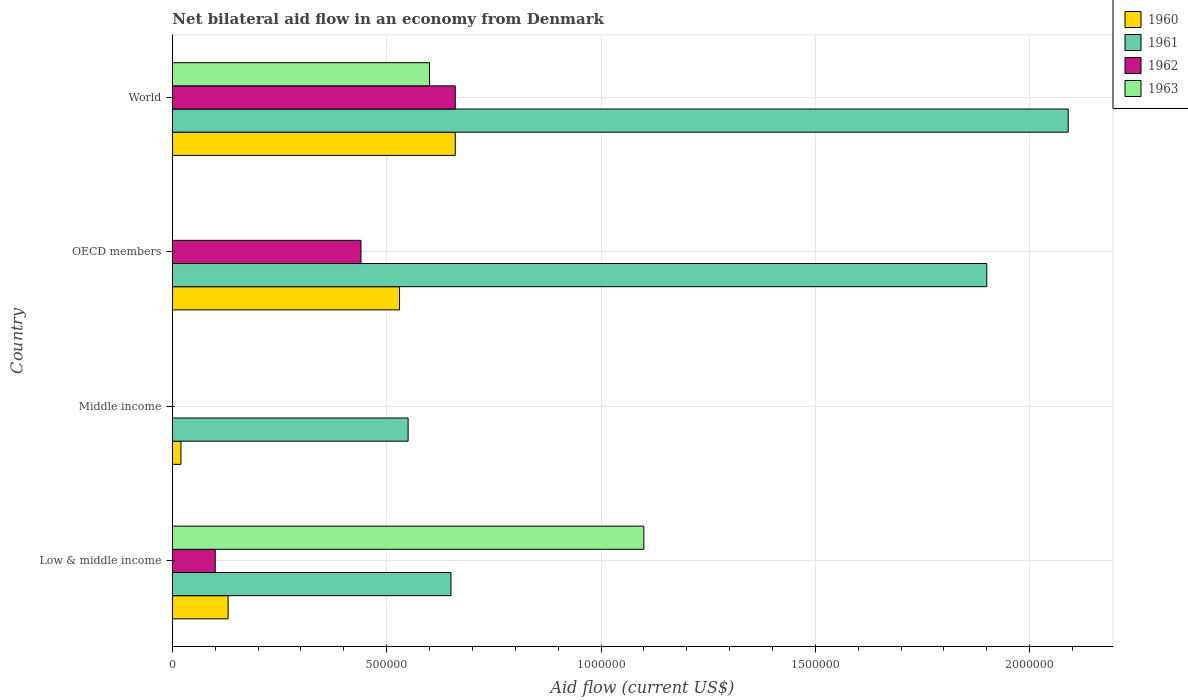Are the number of bars on each tick of the Y-axis equal?
Provide a succinct answer. No. How many bars are there on the 1st tick from the bottom?
Your answer should be very brief. 4. What is the label of the 2nd group of bars from the top?
Ensure brevity in your answer.  OECD members. What is the net bilateral aid flow in 1963 in Low & middle income?
Provide a succinct answer. 1.10e+06. Across all countries, what is the maximum net bilateral aid flow in 1963?
Your response must be concise. 1.10e+06. What is the total net bilateral aid flow in 1963 in the graph?
Your answer should be very brief. 1.70e+06. What is the average net bilateral aid flow in 1960 per country?
Provide a succinct answer. 3.35e+05. What is the difference between the net bilateral aid flow in 1961 and net bilateral aid flow in 1963 in World?
Keep it short and to the point. 1.49e+06. What is the ratio of the net bilateral aid flow in 1961 in Middle income to that in OECD members?
Offer a very short reply. 0.29. What is the difference between the highest and the lowest net bilateral aid flow in 1963?
Your answer should be compact. 1.10e+06. Are the values on the major ticks of X-axis written in scientific E-notation?
Provide a succinct answer. No. Does the graph contain any zero values?
Provide a short and direct response. Yes. Does the graph contain grids?
Keep it short and to the point. Yes. Where does the legend appear in the graph?
Your response must be concise. Top right. What is the title of the graph?
Give a very brief answer. Net bilateral aid flow in an economy from Denmark. Does "1987" appear as one of the legend labels in the graph?
Your response must be concise. No. What is the label or title of the X-axis?
Offer a very short reply. Aid flow (current US$). What is the label or title of the Y-axis?
Offer a terse response. Country. What is the Aid flow (current US$) of 1960 in Low & middle income?
Offer a terse response. 1.30e+05. What is the Aid flow (current US$) in 1961 in Low & middle income?
Provide a short and direct response. 6.50e+05. What is the Aid flow (current US$) in 1962 in Low & middle income?
Keep it short and to the point. 1.00e+05. What is the Aid flow (current US$) of 1963 in Low & middle income?
Offer a very short reply. 1.10e+06. What is the Aid flow (current US$) of 1960 in Middle income?
Keep it short and to the point. 2.00e+04. What is the Aid flow (current US$) in 1960 in OECD members?
Offer a terse response. 5.30e+05. What is the Aid flow (current US$) of 1961 in OECD members?
Make the answer very short. 1.90e+06. What is the Aid flow (current US$) in 1962 in OECD members?
Your answer should be compact. 4.40e+05. What is the Aid flow (current US$) in 1961 in World?
Your answer should be compact. 2.09e+06. Across all countries, what is the maximum Aid flow (current US$) in 1961?
Make the answer very short. 2.09e+06. Across all countries, what is the maximum Aid flow (current US$) of 1962?
Your answer should be compact. 6.60e+05. Across all countries, what is the maximum Aid flow (current US$) in 1963?
Ensure brevity in your answer.  1.10e+06. Across all countries, what is the minimum Aid flow (current US$) of 1960?
Offer a terse response. 2.00e+04. What is the total Aid flow (current US$) in 1960 in the graph?
Your response must be concise. 1.34e+06. What is the total Aid flow (current US$) in 1961 in the graph?
Ensure brevity in your answer.  5.19e+06. What is the total Aid flow (current US$) of 1962 in the graph?
Give a very brief answer. 1.20e+06. What is the total Aid flow (current US$) in 1963 in the graph?
Your response must be concise. 1.70e+06. What is the difference between the Aid flow (current US$) in 1960 in Low & middle income and that in OECD members?
Offer a very short reply. -4.00e+05. What is the difference between the Aid flow (current US$) in 1961 in Low & middle income and that in OECD members?
Your answer should be very brief. -1.25e+06. What is the difference between the Aid flow (current US$) in 1962 in Low & middle income and that in OECD members?
Ensure brevity in your answer.  -3.40e+05. What is the difference between the Aid flow (current US$) of 1960 in Low & middle income and that in World?
Offer a terse response. -5.30e+05. What is the difference between the Aid flow (current US$) in 1961 in Low & middle income and that in World?
Keep it short and to the point. -1.44e+06. What is the difference between the Aid flow (current US$) of 1962 in Low & middle income and that in World?
Offer a very short reply. -5.60e+05. What is the difference between the Aid flow (current US$) of 1963 in Low & middle income and that in World?
Offer a terse response. 5.00e+05. What is the difference between the Aid flow (current US$) in 1960 in Middle income and that in OECD members?
Provide a succinct answer. -5.10e+05. What is the difference between the Aid flow (current US$) of 1961 in Middle income and that in OECD members?
Offer a very short reply. -1.35e+06. What is the difference between the Aid flow (current US$) in 1960 in Middle income and that in World?
Your response must be concise. -6.40e+05. What is the difference between the Aid flow (current US$) in 1961 in Middle income and that in World?
Your answer should be compact. -1.54e+06. What is the difference between the Aid flow (current US$) of 1960 in Low & middle income and the Aid flow (current US$) of 1961 in Middle income?
Your answer should be compact. -4.20e+05. What is the difference between the Aid flow (current US$) in 1960 in Low & middle income and the Aid flow (current US$) in 1961 in OECD members?
Keep it short and to the point. -1.77e+06. What is the difference between the Aid flow (current US$) of 1960 in Low & middle income and the Aid flow (current US$) of 1962 in OECD members?
Your answer should be compact. -3.10e+05. What is the difference between the Aid flow (current US$) of 1960 in Low & middle income and the Aid flow (current US$) of 1961 in World?
Provide a short and direct response. -1.96e+06. What is the difference between the Aid flow (current US$) in 1960 in Low & middle income and the Aid flow (current US$) in 1962 in World?
Give a very brief answer. -5.30e+05. What is the difference between the Aid flow (current US$) of 1960 in Low & middle income and the Aid flow (current US$) of 1963 in World?
Provide a succinct answer. -4.70e+05. What is the difference between the Aid flow (current US$) of 1961 in Low & middle income and the Aid flow (current US$) of 1962 in World?
Provide a short and direct response. -10000. What is the difference between the Aid flow (current US$) in 1961 in Low & middle income and the Aid flow (current US$) in 1963 in World?
Provide a succinct answer. 5.00e+04. What is the difference between the Aid flow (current US$) in 1962 in Low & middle income and the Aid flow (current US$) in 1963 in World?
Your response must be concise. -5.00e+05. What is the difference between the Aid flow (current US$) in 1960 in Middle income and the Aid flow (current US$) in 1961 in OECD members?
Make the answer very short. -1.88e+06. What is the difference between the Aid flow (current US$) in 1960 in Middle income and the Aid flow (current US$) in 1962 in OECD members?
Provide a succinct answer. -4.20e+05. What is the difference between the Aid flow (current US$) in 1960 in Middle income and the Aid flow (current US$) in 1961 in World?
Ensure brevity in your answer.  -2.07e+06. What is the difference between the Aid flow (current US$) in 1960 in Middle income and the Aid flow (current US$) in 1962 in World?
Make the answer very short. -6.40e+05. What is the difference between the Aid flow (current US$) in 1960 in Middle income and the Aid flow (current US$) in 1963 in World?
Keep it short and to the point. -5.80e+05. What is the difference between the Aid flow (current US$) in 1961 in Middle income and the Aid flow (current US$) in 1962 in World?
Provide a short and direct response. -1.10e+05. What is the difference between the Aid flow (current US$) in 1960 in OECD members and the Aid flow (current US$) in 1961 in World?
Offer a very short reply. -1.56e+06. What is the difference between the Aid flow (current US$) in 1960 in OECD members and the Aid flow (current US$) in 1963 in World?
Offer a terse response. -7.00e+04. What is the difference between the Aid flow (current US$) in 1961 in OECD members and the Aid flow (current US$) in 1962 in World?
Make the answer very short. 1.24e+06. What is the difference between the Aid flow (current US$) in 1961 in OECD members and the Aid flow (current US$) in 1963 in World?
Offer a very short reply. 1.30e+06. What is the average Aid flow (current US$) of 1960 per country?
Make the answer very short. 3.35e+05. What is the average Aid flow (current US$) in 1961 per country?
Offer a terse response. 1.30e+06. What is the average Aid flow (current US$) of 1962 per country?
Offer a very short reply. 3.00e+05. What is the average Aid flow (current US$) in 1963 per country?
Your answer should be very brief. 4.25e+05. What is the difference between the Aid flow (current US$) in 1960 and Aid flow (current US$) in 1961 in Low & middle income?
Ensure brevity in your answer.  -5.20e+05. What is the difference between the Aid flow (current US$) in 1960 and Aid flow (current US$) in 1963 in Low & middle income?
Provide a succinct answer. -9.70e+05. What is the difference between the Aid flow (current US$) of 1961 and Aid flow (current US$) of 1962 in Low & middle income?
Provide a short and direct response. 5.50e+05. What is the difference between the Aid flow (current US$) in 1961 and Aid flow (current US$) in 1963 in Low & middle income?
Offer a very short reply. -4.50e+05. What is the difference between the Aid flow (current US$) of 1962 and Aid flow (current US$) of 1963 in Low & middle income?
Your response must be concise. -1.00e+06. What is the difference between the Aid flow (current US$) of 1960 and Aid flow (current US$) of 1961 in Middle income?
Provide a short and direct response. -5.30e+05. What is the difference between the Aid flow (current US$) of 1960 and Aid flow (current US$) of 1961 in OECD members?
Your answer should be compact. -1.37e+06. What is the difference between the Aid flow (current US$) in 1961 and Aid flow (current US$) in 1962 in OECD members?
Provide a succinct answer. 1.46e+06. What is the difference between the Aid flow (current US$) in 1960 and Aid flow (current US$) in 1961 in World?
Keep it short and to the point. -1.43e+06. What is the difference between the Aid flow (current US$) of 1960 and Aid flow (current US$) of 1962 in World?
Provide a short and direct response. 0. What is the difference between the Aid flow (current US$) of 1960 and Aid flow (current US$) of 1963 in World?
Provide a succinct answer. 6.00e+04. What is the difference between the Aid flow (current US$) in 1961 and Aid flow (current US$) in 1962 in World?
Your answer should be very brief. 1.43e+06. What is the difference between the Aid flow (current US$) of 1961 and Aid flow (current US$) of 1963 in World?
Make the answer very short. 1.49e+06. What is the ratio of the Aid flow (current US$) of 1960 in Low & middle income to that in Middle income?
Your answer should be compact. 6.5. What is the ratio of the Aid flow (current US$) of 1961 in Low & middle income to that in Middle income?
Make the answer very short. 1.18. What is the ratio of the Aid flow (current US$) of 1960 in Low & middle income to that in OECD members?
Provide a short and direct response. 0.25. What is the ratio of the Aid flow (current US$) in 1961 in Low & middle income to that in OECD members?
Offer a terse response. 0.34. What is the ratio of the Aid flow (current US$) in 1962 in Low & middle income to that in OECD members?
Provide a succinct answer. 0.23. What is the ratio of the Aid flow (current US$) in 1960 in Low & middle income to that in World?
Give a very brief answer. 0.2. What is the ratio of the Aid flow (current US$) in 1961 in Low & middle income to that in World?
Offer a terse response. 0.31. What is the ratio of the Aid flow (current US$) in 1962 in Low & middle income to that in World?
Your answer should be compact. 0.15. What is the ratio of the Aid flow (current US$) in 1963 in Low & middle income to that in World?
Keep it short and to the point. 1.83. What is the ratio of the Aid flow (current US$) in 1960 in Middle income to that in OECD members?
Provide a short and direct response. 0.04. What is the ratio of the Aid flow (current US$) in 1961 in Middle income to that in OECD members?
Provide a short and direct response. 0.29. What is the ratio of the Aid flow (current US$) of 1960 in Middle income to that in World?
Give a very brief answer. 0.03. What is the ratio of the Aid flow (current US$) in 1961 in Middle income to that in World?
Your answer should be very brief. 0.26. What is the ratio of the Aid flow (current US$) in 1960 in OECD members to that in World?
Offer a very short reply. 0.8. What is the ratio of the Aid flow (current US$) of 1961 in OECD members to that in World?
Your answer should be compact. 0.91. What is the ratio of the Aid flow (current US$) in 1962 in OECD members to that in World?
Provide a short and direct response. 0.67. What is the difference between the highest and the second highest Aid flow (current US$) of 1961?
Your answer should be compact. 1.90e+05. What is the difference between the highest and the second highest Aid flow (current US$) of 1962?
Keep it short and to the point. 2.20e+05. What is the difference between the highest and the lowest Aid flow (current US$) of 1960?
Keep it short and to the point. 6.40e+05. What is the difference between the highest and the lowest Aid flow (current US$) of 1961?
Give a very brief answer. 1.54e+06. What is the difference between the highest and the lowest Aid flow (current US$) in 1962?
Your answer should be compact. 6.60e+05. What is the difference between the highest and the lowest Aid flow (current US$) in 1963?
Provide a short and direct response. 1.10e+06. 